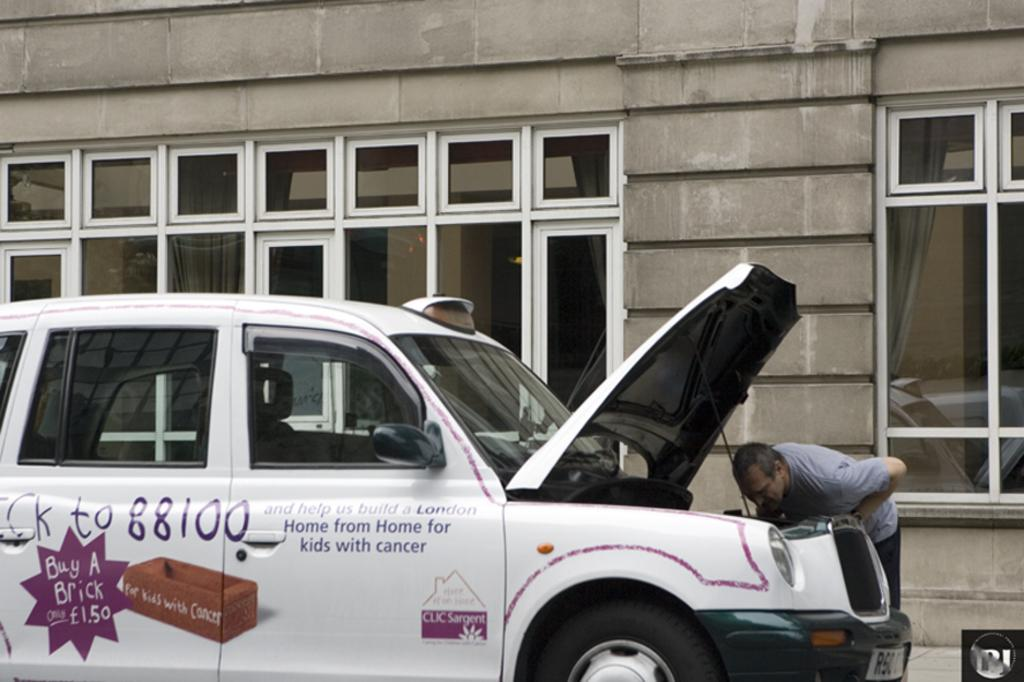<image>
Create a compact narrative representing the image presented. The car is asking for help to build a London home from Home for kids with cancer. 